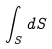Convert formula to latex. <formula><loc_0><loc_0><loc_500><loc_500>\int _ { S } d S</formula> 